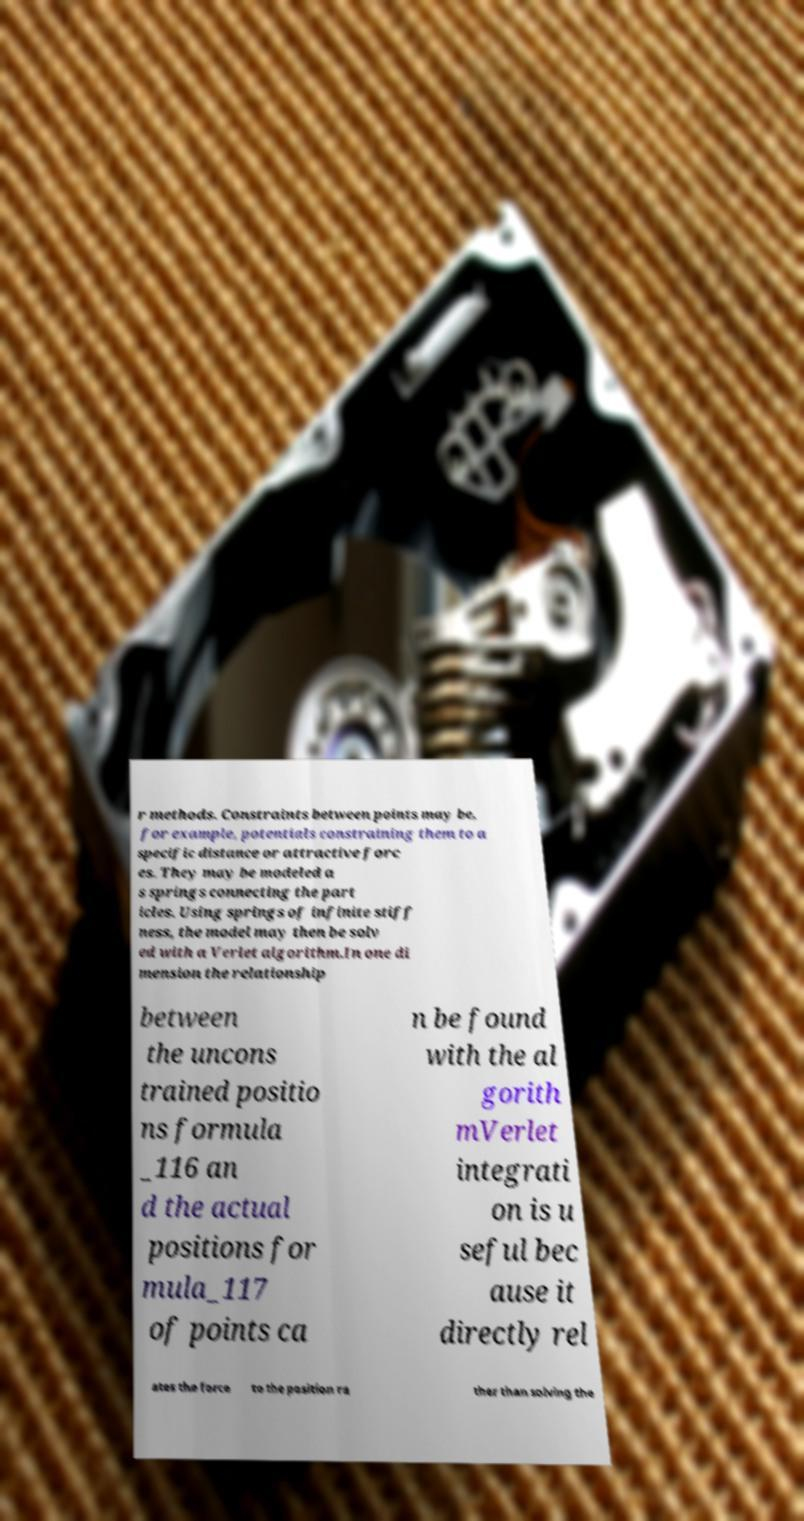Can you accurately transcribe the text from the provided image for me? r methods. Constraints between points may be, for example, potentials constraining them to a specific distance or attractive forc es. They may be modeled a s springs connecting the part icles. Using springs of infinite stiff ness, the model may then be solv ed with a Verlet algorithm.In one di mension the relationship between the uncons trained positio ns formula _116 an d the actual positions for mula_117 of points ca n be found with the al gorith mVerlet integrati on is u seful bec ause it directly rel ates the force to the position ra ther than solving the 